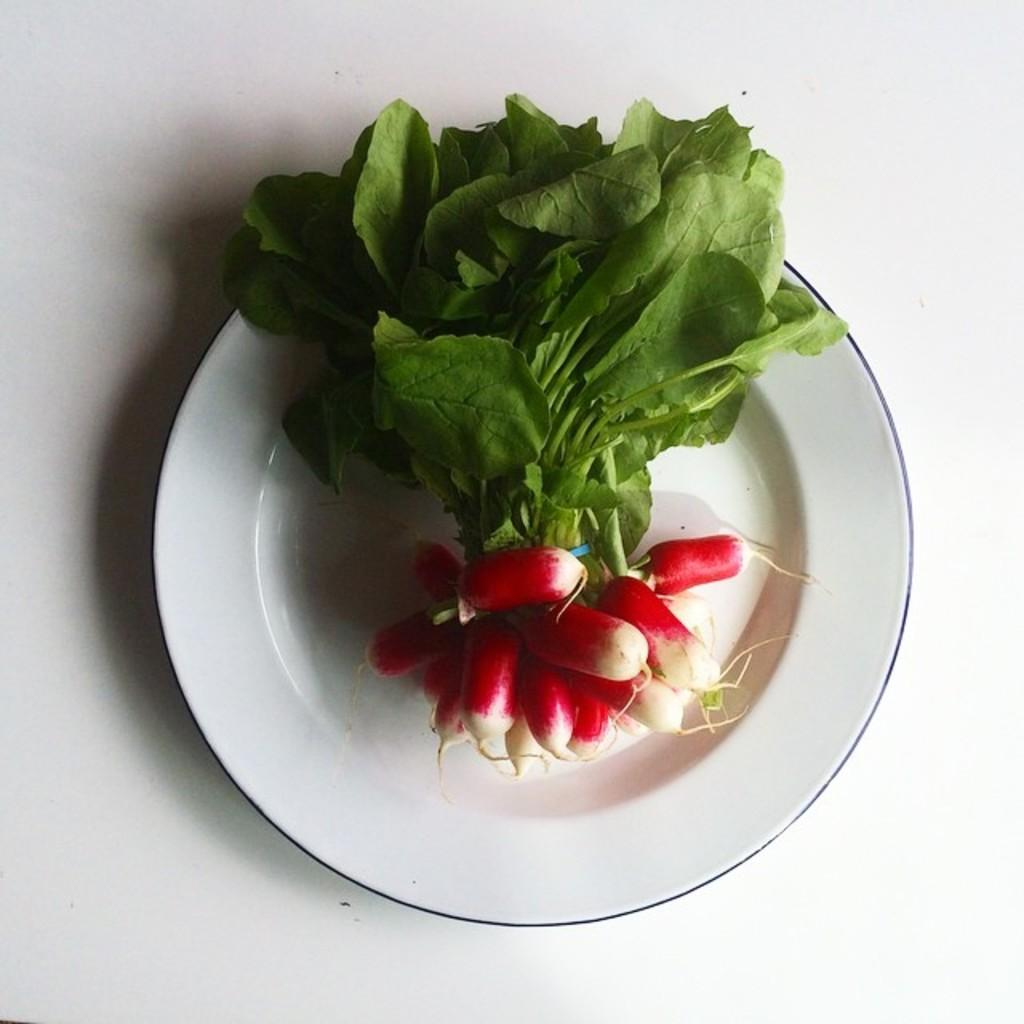What is on the plate that is visible in the image? The plate contains leaves and root vegetables. What is the color of the surface on which the plate is placed? The plate is placed on a white surface. What type of soda is being served at the meeting in the image? There is no soda or meeting present in the image; it features a plate with leaves and root vegetables on a white surface. 